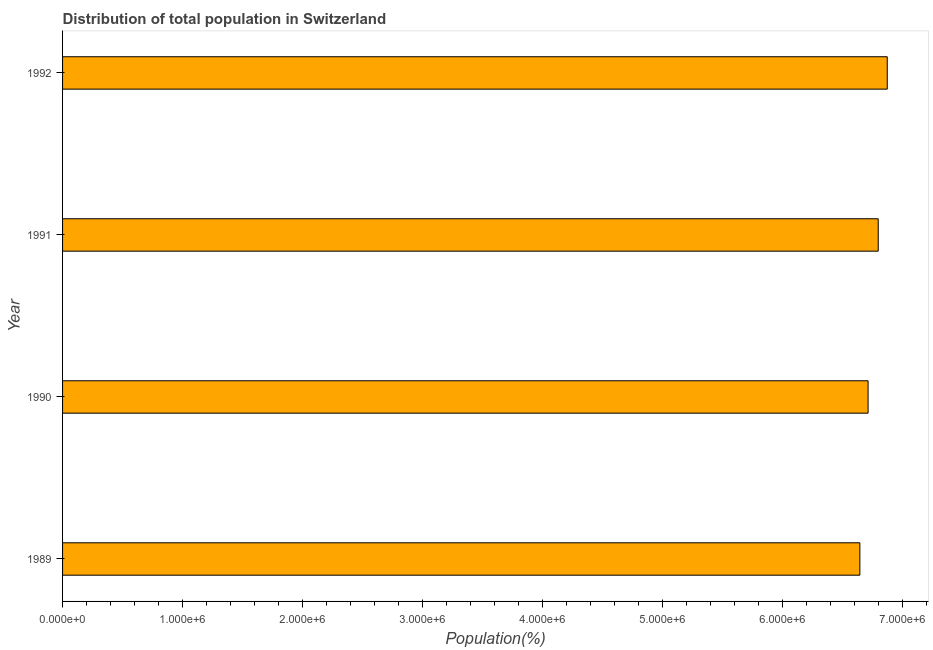What is the title of the graph?
Keep it short and to the point. Distribution of total population in Switzerland . What is the label or title of the X-axis?
Provide a succinct answer. Population(%). What is the population in 1991?
Keep it short and to the point. 6.80e+06. Across all years, what is the maximum population?
Provide a succinct answer. 6.88e+06. Across all years, what is the minimum population?
Your answer should be compact. 6.65e+06. What is the sum of the population?
Your answer should be very brief. 2.70e+07. What is the difference between the population in 1990 and 1992?
Provide a succinct answer. -1.60e+05. What is the average population per year?
Provide a short and direct response. 6.76e+06. What is the median population?
Ensure brevity in your answer.  6.76e+06. Do a majority of the years between 1990 and 1989 (inclusive) have population greater than 600000 %?
Your response must be concise. No. What is the ratio of the population in 1989 to that in 1991?
Provide a short and direct response. 0.98. Is the population in 1990 less than that in 1991?
Offer a very short reply. Yes. Is the difference between the population in 1990 and 1992 greater than the difference between any two years?
Your answer should be very brief. No. What is the difference between the highest and the second highest population?
Offer a terse response. 7.54e+04. Is the sum of the population in 1989 and 1992 greater than the maximum population across all years?
Your answer should be compact. Yes. What is the difference between the highest and the lowest population?
Make the answer very short. 2.28e+05. In how many years, is the population greater than the average population taken over all years?
Provide a succinct answer. 2. Are the values on the major ticks of X-axis written in scientific E-notation?
Provide a short and direct response. Yes. What is the Population(%) in 1989?
Your answer should be very brief. 6.65e+06. What is the Population(%) of 1990?
Provide a succinct answer. 6.72e+06. What is the Population(%) in 1991?
Your response must be concise. 6.80e+06. What is the Population(%) in 1992?
Provide a succinct answer. 6.88e+06. What is the difference between the Population(%) in 1989 and 1990?
Keep it short and to the point. -6.86e+04. What is the difference between the Population(%) in 1989 and 1991?
Your answer should be compact. -1.53e+05. What is the difference between the Population(%) in 1989 and 1992?
Your answer should be compact. -2.28e+05. What is the difference between the Population(%) in 1990 and 1991?
Keep it short and to the point. -8.45e+04. What is the difference between the Population(%) in 1990 and 1992?
Your response must be concise. -1.60e+05. What is the difference between the Population(%) in 1991 and 1992?
Offer a terse response. -7.54e+04. What is the ratio of the Population(%) in 1989 to that in 1990?
Your answer should be very brief. 0.99. What is the ratio of the Population(%) in 1989 to that in 1991?
Offer a terse response. 0.98. What is the ratio of the Population(%) in 1990 to that in 1992?
Offer a very short reply. 0.98. What is the ratio of the Population(%) in 1991 to that in 1992?
Offer a terse response. 0.99. 